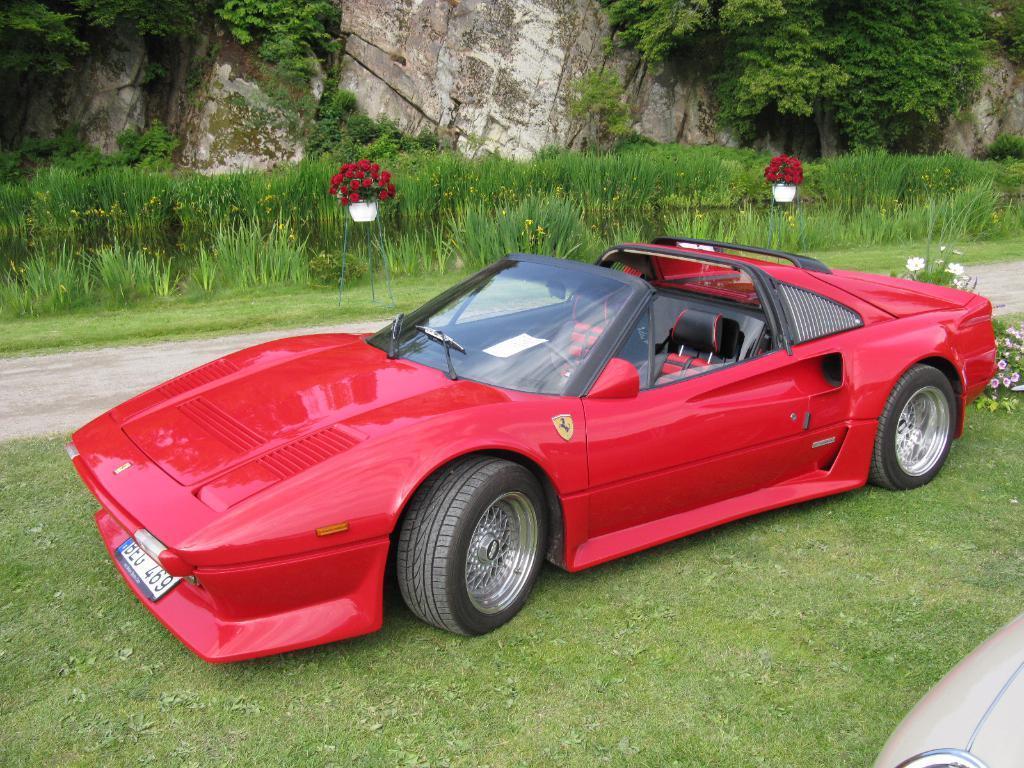How would you summarize this image in a sentence or two? In this picture we can see a car on the grass. We can see some grass on both sides of the path. There are a few flowers and another car is visible on the right side. We can see red flowers in the flower pots and stands on the grass. There are a few plants on the rocks visible in the background. 